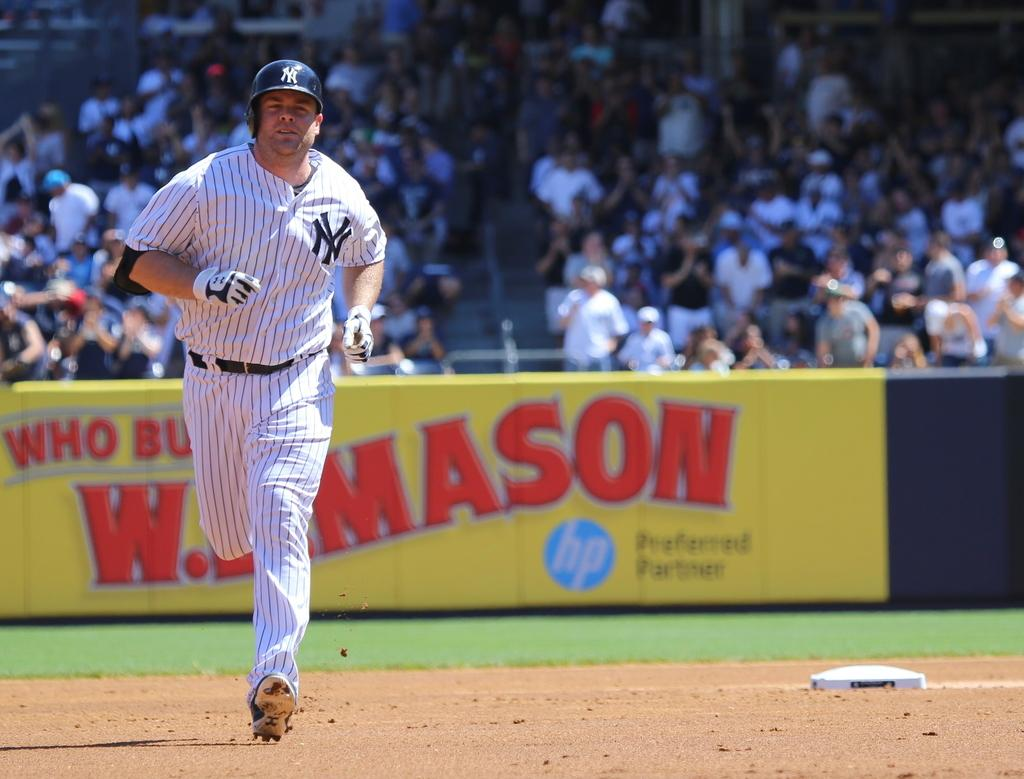Provide a one-sentence caption for the provided image. A New York player runs the bases during a baseball game. 